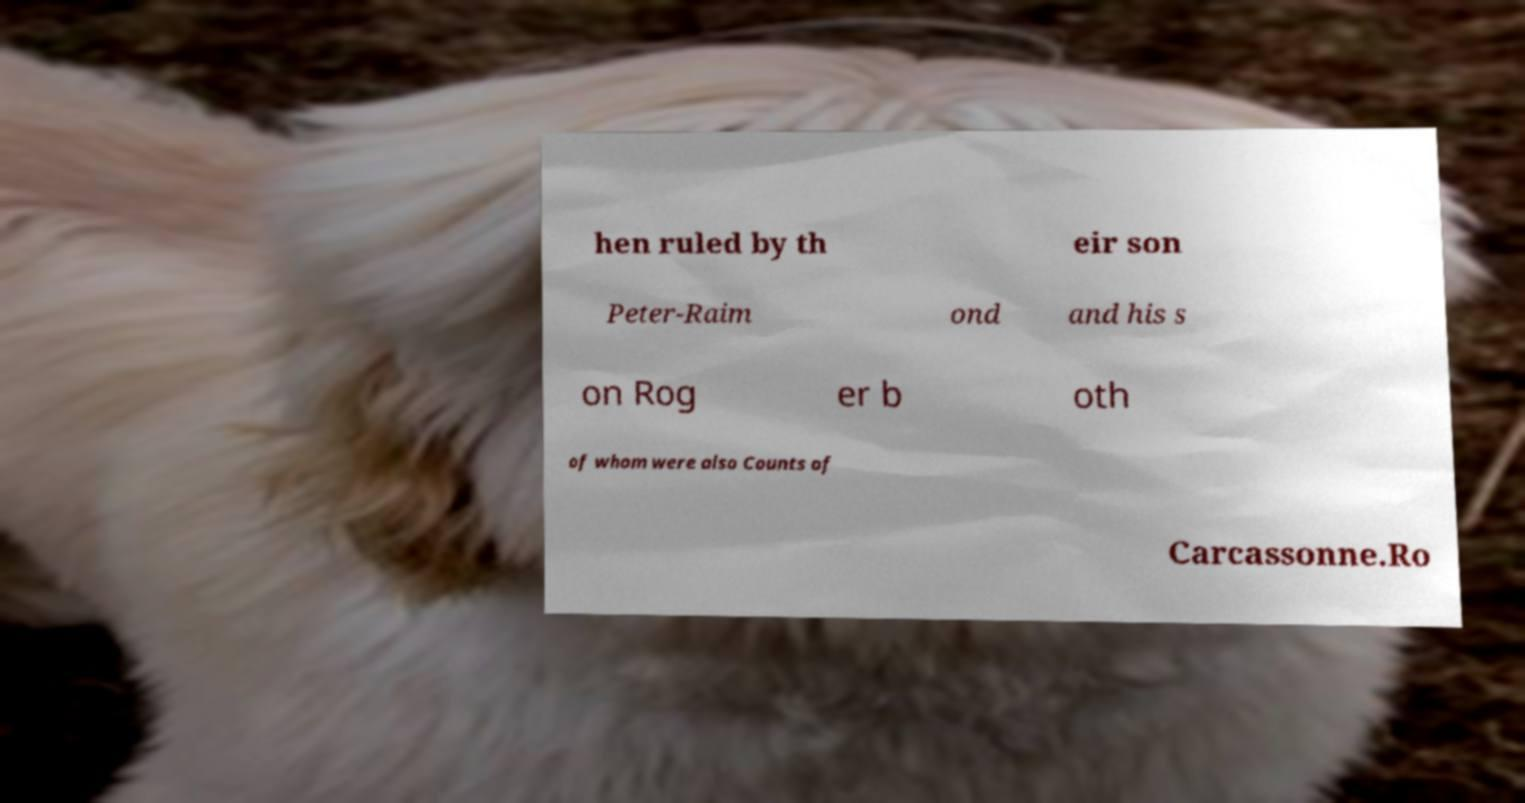For documentation purposes, I need the text within this image transcribed. Could you provide that? hen ruled by th eir son Peter-Raim ond and his s on Rog er b oth of whom were also Counts of Carcassonne.Ro 